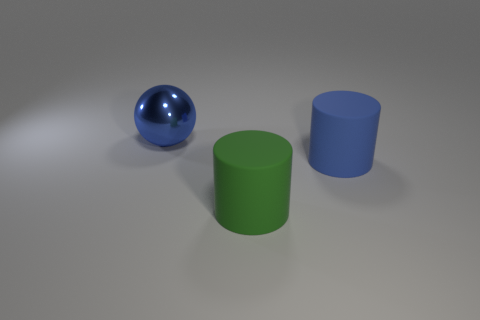Add 1 green rubber cylinders. How many objects exist? 4 Subtract all spheres. How many objects are left? 2 Subtract all yellow cylinders. Subtract all gray blocks. How many cylinders are left? 2 Subtract all large blue things. Subtract all yellow shiny things. How many objects are left? 1 Add 1 large blue shiny things. How many large blue shiny things are left? 2 Add 3 green matte things. How many green matte things exist? 4 Subtract all blue cylinders. How many cylinders are left? 1 Subtract 0 blue cubes. How many objects are left? 3 